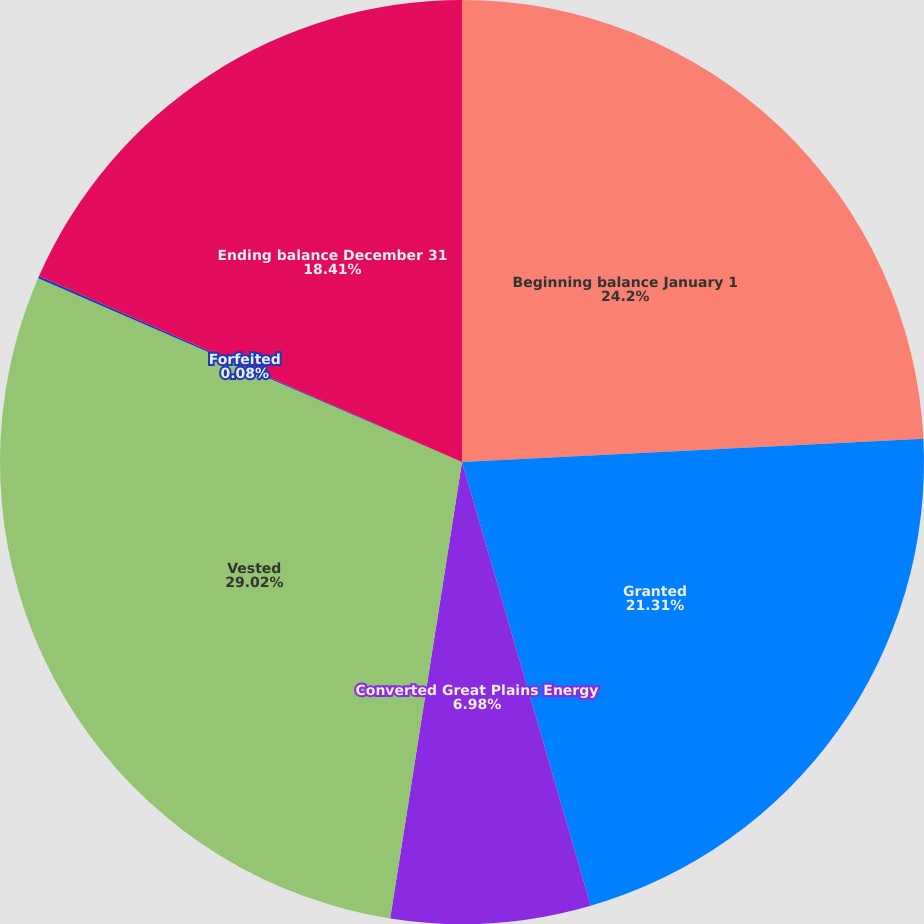Convert chart to OTSL. <chart><loc_0><loc_0><loc_500><loc_500><pie_chart><fcel>Beginning balance January 1<fcel>Granted<fcel>Converted Great Plains Energy<fcel>Vested<fcel>Forfeited<fcel>Ending balance December 31<nl><fcel>24.2%<fcel>21.31%<fcel>6.98%<fcel>29.03%<fcel>0.08%<fcel>18.41%<nl></chart> 